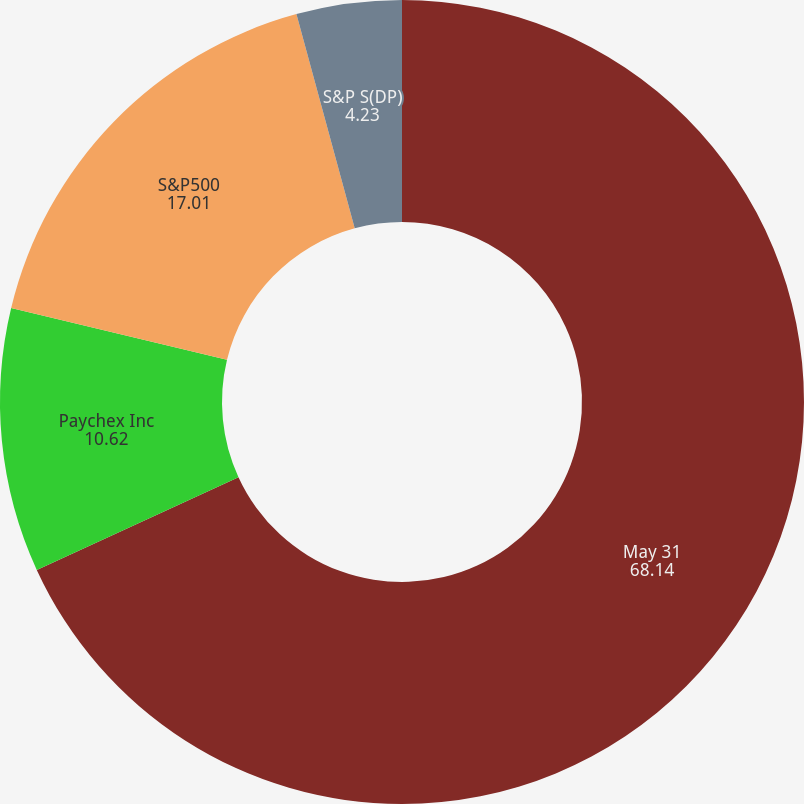<chart> <loc_0><loc_0><loc_500><loc_500><pie_chart><fcel>May 31<fcel>Paychex Inc<fcel>S&P500<fcel>S&P S(DP)<nl><fcel>68.14%<fcel>10.62%<fcel>17.01%<fcel>4.23%<nl></chart> 